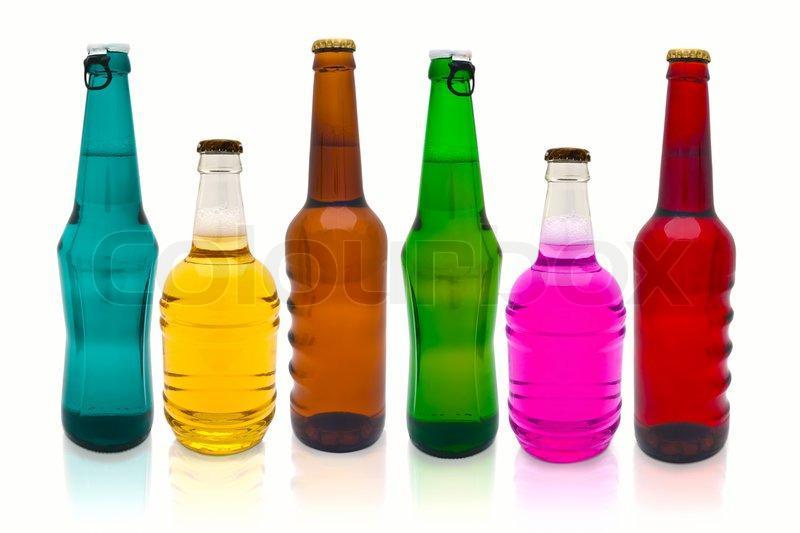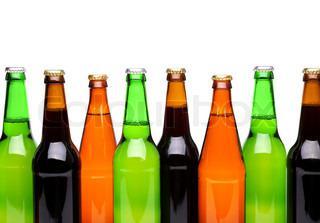The first image is the image on the left, the second image is the image on the right. Given the left and right images, does the statement "There is no more than 8 bottles." hold true? Answer yes or no. No. The first image is the image on the left, the second image is the image on the right. Evaluate the accuracy of this statement regarding the images: "The bottles in the image on the left don't have lablels.". Is it true? Answer yes or no. Yes. 